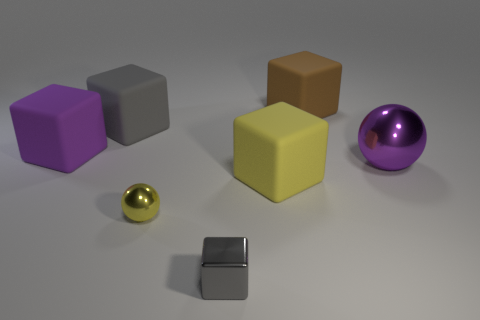How do the materials of the objects in the image affect the lighting and shadows we see? The materials of the objects have distinct effects on the lighting and shadows. The shiny, smooth surfaces of the metallic balls reflect light and create crisp, clear reflections. Matte surfaces, like that of the cubes, diffuse light, resulting in softer shadows and less defined reflections. 